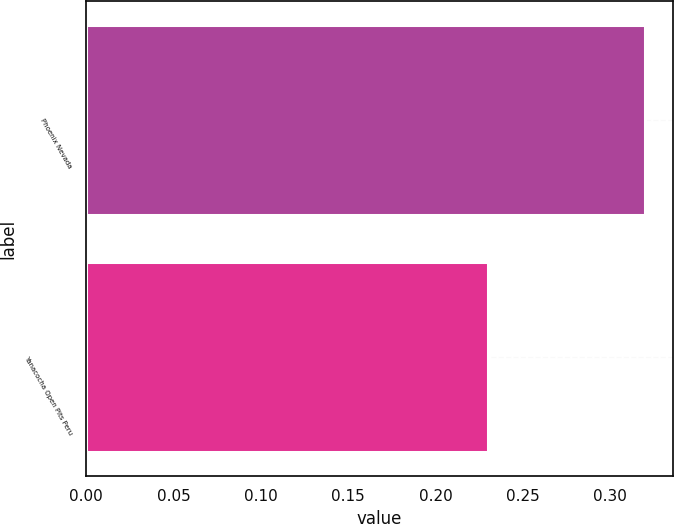Convert chart. <chart><loc_0><loc_0><loc_500><loc_500><bar_chart><fcel>Phoenix Nevada<fcel>Yanacocha Open Pits Peru<nl><fcel>0.32<fcel>0.23<nl></chart> 